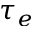Convert formula to latex. <formula><loc_0><loc_0><loc_500><loc_500>\tau _ { e }</formula> 